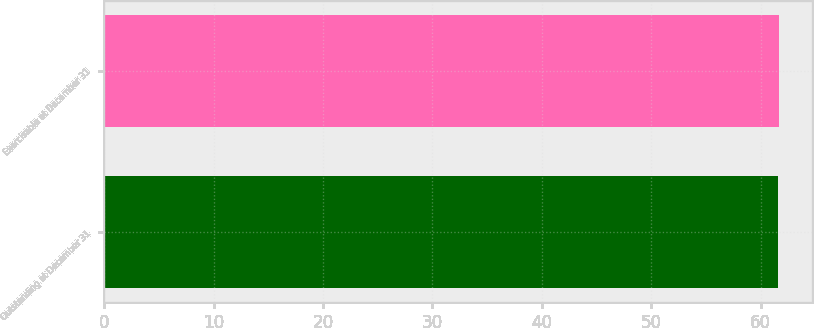Convert chart. <chart><loc_0><loc_0><loc_500><loc_500><bar_chart><fcel>Outstanding at December 31<fcel>Exercisable at December 31<nl><fcel>61.55<fcel>61.65<nl></chart> 